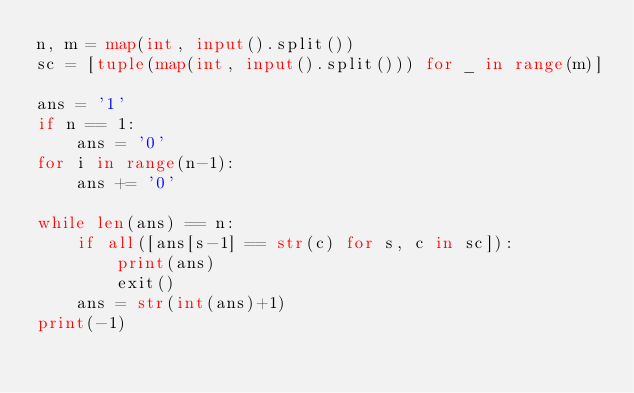Convert code to text. <code><loc_0><loc_0><loc_500><loc_500><_Python_>n, m = map(int, input().split())
sc = [tuple(map(int, input().split())) for _ in range(m)]

ans = '1'
if n == 1:
    ans = '0'
for i in range(n-1):
    ans += '0'

while len(ans) == n:
    if all([ans[s-1] == str(c) for s, c in sc]):
        print(ans)
        exit()
    ans = str(int(ans)+1)
print(-1)</code> 